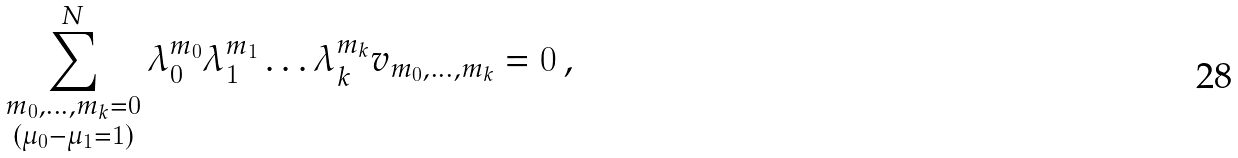<formula> <loc_0><loc_0><loc_500><loc_500>\sum _ { \substack { m _ { 0 } , \dots , m _ { k } = 0 \\ ( \mu _ { 0 } - \mu _ { 1 } = 1 ) } } ^ { N } \lambda _ { 0 } ^ { m _ { 0 } } \lambda _ { 1 } ^ { m _ { 1 } } \dots \lambda _ { k } ^ { m _ { k } } v _ { m _ { 0 } , \dots , m _ { k } } = 0 \, ,</formula> 